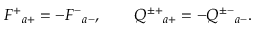Convert formula to latex. <formula><loc_0><loc_0><loc_500><loc_500>F ^ { + _ { a + } = - F ^ { - _ { a - } , \quad Q ^ { \pm + _ { a + } = - Q ^ { \pm - _ { a - } .</formula> 